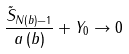Convert formula to latex. <formula><loc_0><loc_0><loc_500><loc_500>\frac { \tilde { S } _ { N \left ( b \right ) - 1 } } { a \left ( b \right ) } + Y _ { 0 } \rightarrow 0</formula> 